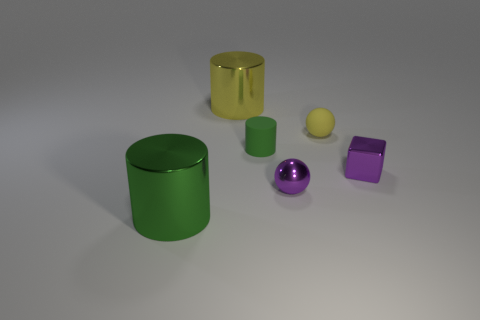Add 2 yellow balls. How many objects exist? 8 Subtract all blocks. How many objects are left? 5 Add 6 tiny rubber objects. How many tiny rubber objects are left? 8 Add 3 big shiny spheres. How many big shiny spheres exist? 3 Subtract 1 yellow cylinders. How many objects are left? 5 Subtract all cylinders. Subtract all purple shiny things. How many objects are left? 1 